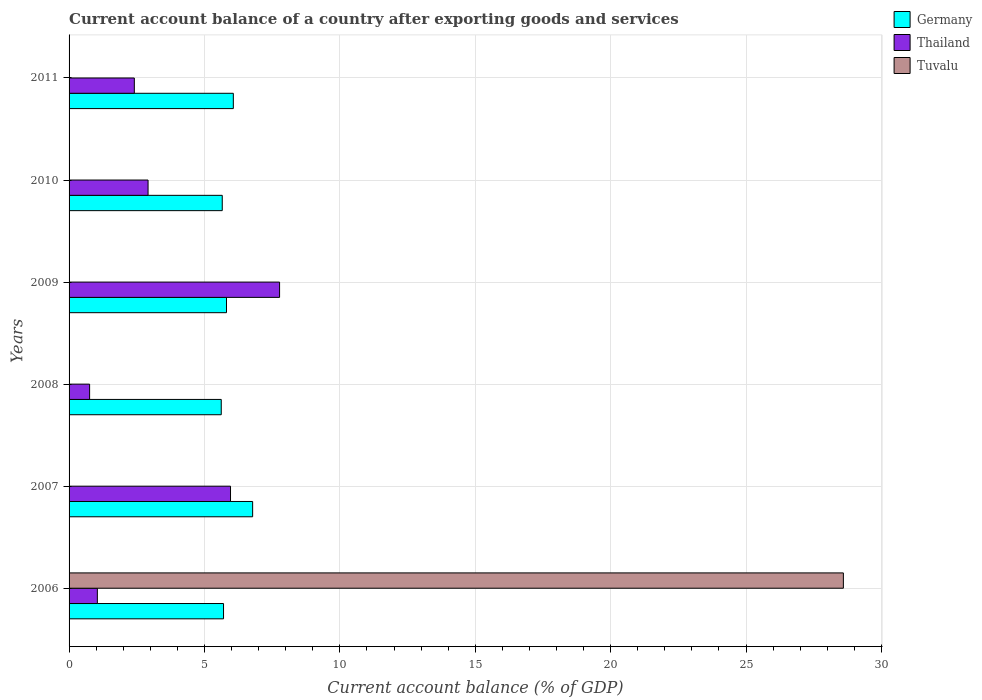How many different coloured bars are there?
Give a very brief answer. 3. Are the number of bars on each tick of the Y-axis equal?
Provide a succinct answer. No. How many bars are there on the 2nd tick from the bottom?
Offer a terse response. 2. In how many cases, is the number of bars for a given year not equal to the number of legend labels?
Give a very brief answer. 5. What is the account balance in Thailand in 2008?
Ensure brevity in your answer.  0.76. Across all years, what is the maximum account balance in Thailand?
Offer a terse response. 7.77. What is the total account balance in Thailand in the graph?
Ensure brevity in your answer.  20.87. What is the difference between the account balance in Germany in 2006 and that in 2007?
Offer a very short reply. -1.08. What is the difference between the account balance in Tuvalu in 2009 and the account balance in Germany in 2008?
Ensure brevity in your answer.  -5.62. What is the average account balance in Thailand per year?
Offer a terse response. 3.48. In the year 2007, what is the difference between the account balance in Thailand and account balance in Germany?
Give a very brief answer. -0.82. In how many years, is the account balance in Thailand greater than 20 %?
Make the answer very short. 0. What is the ratio of the account balance in Thailand in 2006 to that in 2009?
Keep it short and to the point. 0.13. Is the difference between the account balance in Thailand in 2006 and 2009 greater than the difference between the account balance in Germany in 2006 and 2009?
Your answer should be compact. No. What is the difference between the highest and the second highest account balance in Thailand?
Your response must be concise. 1.81. What is the difference between the highest and the lowest account balance in Tuvalu?
Offer a very short reply. 28.6. In how many years, is the account balance in Germany greater than the average account balance in Germany taken over all years?
Provide a short and direct response. 2. Is the sum of the account balance in Germany in 2007 and 2011 greater than the maximum account balance in Tuvalu across all years?
Keep it short and to the point. No. Is it the case that in every year, the sum of the account balance in Thailand and account balance in Tuvalu is greater than the account balance in Germany?
Your answer should be compact. No. How many bars are there?
Provide a short and direct response. 13. Are all the bars in the graph horizontal?
Give a very brief answer. Yes. What is the difference between two consecutive major ticks on the X-axis?
Your answer should be very brief. 5. Are the values on the major ticks of X-axis written in scientific E-notation?
Your answer should be compact. No. Does the graph contain any zero values?
Give a very brief answer. Yes. Does the graph contain grids?
Offer a terse response. Yes. Where does the legend appear in the graph?
Make the answer very short. Top right. What is the title of the graph?
Your answer should be very brief. Current account balance of a country after exporting goods and services. Does "Sub-Saharan Africa (all income levels)" appear as one of the legend labels in the graph?
Your answer should be compact. No. What is the label or title of the X-axis?
Offer a terse response. Current account balance (% of GDP). What is the Current account balance (% of GDP) in Germany in 2006?
Your answer should be compact. 5.7. What is the Current account balance (% of GDP) in Thailand in 2006?
Your response must be concise. 1.04. What is the Current account balance (% of GDP) in Tuvalu in 2006?
Give a very brief answer. 28.6. What is the Current account balance (% of GDP) of Germany in 2007?
Provide a short and direct response. 6.78. What is the Current account balance (% of GDP) in Thailand in 2007?
Ensure brevity in your answer.  5.96. What is the Current account balance (% of GDP) in Germany in 2008?
Provide a short and direct response. 5.62. What is the Current account balance (% of GDP) of Thailand in 2008?
Keep it short and to the point. 0.76. What is the Current account balance (% of GDP) in Tuvalu in 2008?
Give a very brief answer. 0. What is the Current account balance (% of GDP) of Germany in 2009?
Make the answer very short. 5.81. What is the Current account balance (% of GDP) of Thailand in 2009?
Make the answer very short. 7.77. What is the Current account balance (% of GDP) of Germany in 2010?
Provide a succinct answer. 5.66. What is the Current account balance (% of GDP) in Thailand in 2010?
Provide a short and direct response. 2.92. What is the Current account balance (% of GDP) of Germany in 2011?
Give a very brief answer. 6.07. What is the Current account balance (% of GDP) in Thailand in 2011?
Provide a short and direct response. 2.41. Across all years, what is the maximum Current account balance (% of GDP) of Germany?
Your answer should be very brief. 6.78. Across all years, what is the maximum Current account balance (% of GDP) of Thailand?
Ensure brevity in your answer.  7.77. Across all years, what is the maximum Current account balance (% of GDP) in Tuvalu?
Offer a very short reply. 28.6. Across all years, what is the minimum Current account balance (% of GDP) in Germany?
Offer a very short reply. 5.62. Across all years, what is the minimum Current account balance (% of GDP) of Thailand?
Provide a succinct answer. 0.76. What is the total Current account balance (% of GDP) of Germany in the graph?
Provide a short and direct response. 35.64. What is the total Current account balance (% of GDP) of Thailand in the graph?
Ensure brevity in your answer.  20.87. What is the total Current account balance (% of GDP) of Tuvalu in the graph?
Your answer should be compact. 28.6. What is the difference between the Current account balance (% of GDP) of Germany in 2006 and that in 2007?
Your answer should be compact. -1.08. What is the difference between the Current account balance (% of GDP) in Thailand in 2006 and that in 2007?
Provide a succinct answer. -4.92. What is the difference between the Current account balance (% of GDP) in Germany in 2006 and that in 2008?
Offer a very short reply. 0.08. What is the difference between the Current account balance (% of GDP) in Thailand in 2006 and that in 2008?
Your answer should be compact. 0.29. What is the difference between the Current account balance (% of GDP) of Germany in 2006 and that in 2009?
Provide a short and direct response. -0.11. What is the difference between the Current account balance (% of GDP) of Thailand in 2006 and that in 2009?
Offer a very short reply. -6.73. What is the difference between the Current account balance (% of GDP) of Germany in 2006 and that in 2010?
Your response must be concise. 0.05. What is the difference between the Current account balance (% of GDP) of Thailand in 2006 and that in 2010?
Make the answer very short. -1.87. What is the difference between the Current account balance (% of GDP) in Germany in 2006 and that in 2011?
Ensure brevity in your answer.  -0.36. What is the difference between the Current account balance (% of GDP) of Thailand in 2006 and that in 2011?
Ensure brevity in your answer.  -1.37. What is the difference between the Current account balance (% of GDP) in Germany in 2007 and that in 2008?
Make the answer very short. 1.16. What is the difference between the Current account balance (% of GDP) in Thailand in 2007 and that in 2008?
Your response must be concise. 5.2. What is the difference between the Current account balance (% of GDP) in Germany in 2007 and that in 2009?
Provide a short and direct response. 0.97. What is the difference between the Current account balance (% of GDP) in Thailand in 2007 and that in 2009?
Offer a very short reply. -1.81. What is the difference between the Current account balance (% of GDP) of Germany in 2007 and that in 2010?
Keep it short and to the point. 1.12. What is the difference between the Current account balance (% of GDP) of Thailand in 2007 and that in 2010?
Offer a terse response. 3.04. What is the difference between the Current account balance (% of GDP) in Germany in 2007 and that in 2011?
Provide a short and direct response. 0.71. What is the difference between the Current account balance (% of GDP) in Thailand in 2007 and that in 2011?
Give a very brief answer. 3.55. What is the difference between the Current account balance (% of GDP) in Germany in 2008 and that in 2009?
Offer a terse response. -0.19. What is the difference between the Current account balance (% of GDP) in Thailand in 2008 and that in 2009?
Keep it short and to the point. -7.02. What is the difference between the Current account balance (% of GDP) in Germany in 2008 and that in 2010?
Your answer should be very brief. -0.04. What is the difference between the Current account balance (% of GDP) in Thailand in 2008 and that in 2010?
Offer a terse response. -2.16. What is the difference between the Current account balance (% of GDP) in Germany in 2008 and that in 2011?
Offer a very short reply. -0.45. What is the difference between the Current account balance (% of GDP) of Thailand in 2008 and that in 2011?
Ensure brevity in your answer.  -1.65. What is the difference between the Current account balance (% of GDP) of Germany in 2009 and that in 2010?
Give a very brief answer. 0.16. What is the difference between the Current account balance (% of GDP) in Thailand in 2009 and that in 2010?
Your answer should be very brief. 4.86. What is the difference between the Current account balance (% of GDP) in Germany in 2009 and that in 2011?
Provide a succinct answer. -0.25. What is the difference between the Current account balance (% of GDP) of Thailand in 2009 and that in 2011?
Offer a terse response. 5.36. What is the difference between the Current account balance (% of GDP) of Germany in 2010 and that in 2011?
Offer a very short reply. -0.41. What is the difference between the Current account balance (% of GDP) in Thailand in 2010 and that in 2011?
Give a very brief answer. 0.51. What is the difference between the Current account balance (% of GDP) in Germany in 2006 and the Current account balance (% of GDP) in Thailand in 2007?
Ensure brevity in your answer.  -0.26. What is the difference between the Current account balance (% of GDP) in Germany in 2006 and the Current account balance (% of GDP) in Thailand in 2008?
Your answer should be very brief. 4.95. What is the difference between the Current account balance (% of GDP) in Germany in 2006 and the Current account balance (% of GDP) in Thailand in 2009?
Provide a short and direct response. -2.07. What is the difference between the Current account balance (% of GDP) in Germany in 2006 and the Current account balance (% of GDP) in Thailand in 2010?
Offer a very short reply. 2.79. What is the difference between the Current account balance (% of GDP) in Germany in 2006 and the Current account balance (% of GDP) in Thailand in 2011?
Offer a very short reply. 3.29. What is the difference between the Current account balance (% of GDP) in Germany in 2007 and the Current account balance (% of GDP) in Thailand in 2008?
Your answer should be compact. 6.02. What is the difference between the Current account balance (% of GDP) in Germany in 2007 and the Current account balance (% of GDP) in Thailand in 2009?
Make the answer very short. -0.99. What is the difference between the Current account balance (% of GDP) in Germany in 2007 and the Current account balance (% of GDP) in Thailand in 2010?
Your answer should be very brief. 3.86. What is the difference between the Current account balance (% of GDP) in Germany in 2007 and the Current account balance (% of GDP) in Thailand in 2011?
Ensure brevity in your answer.  4.37. What is the difference between the Current account balance (% of GDP) of Germany in 2008 and the Current account balance (% of GDP) of Thailand in 2009?
Provide a short and direct response. -2.15. What is the difference between the Current account balance (% of GDP) in Germany in 2008 and the Current account balance (% of GDP) in Thailand in 2010?
Provide a succinct answer. 2.7. What is the difference between the Current account balance (% of GDP) in Germany in 2008 and the Current account balance (% of GDP) in Thailand in 2011?
Provide a short and direct response. 3.21. What is the difference between the Current account balance (% of GDP) in Germany in 2009 and the Current account balance (% of GDP) in Thailand in 2010?
Keep it short and to the point. 2.9. What is the difference between the Current account balance (% of GDP) in Germany in 2009 and the Current account balance (% of GDP) in Thailand in 2011?
Offer a terse response. 3.4. What is the difference between the Current account balance (% of GDP) of Germany in 2010 and the Current account balance (% of GDP) of Thailand in 2011?
Your answer should be very brief. 3.25. What is the average Current account balance (% of GDP) of Germany per year?
Offer a very short reply. 5.94. What is the average Current account balance (% of GDP) of Thailand per year?
Offer a terse response. 3.48. What is the average Current account balance (% of GDP) of Tuvalu per year?
Make the answer very short. 4.77. In the year 2006, what is the difference between the Current account balance (% of GDP) in Germany and Current account balance (% of GDP) in Thailand?
Provide a short and direct response. 4.66. In the year 2006, what is the difference between the Current account balance (% of GDP) in Germany and Current account balance (% of GDP) in Tuvalu?
Keep it short and to the point. -22.89. In the year 2006, what is the difference between the Current account balance (% of GDP) of Thailand and Current account balance (% of GDP) of Tuvalu?
Your response must be concise. -27.55. In the year 2007, what is the difference between the Current account balance (% of GDP) of Germany and Current account balance (% of GDP) of Thailand?
Provide a short and direct response. 0.82. In the year 2008, what is the difference between the Current account balance (% of GDP) in Germany and Current account balance (% of GDP) in Thailand?
Your answer should be compact. 4.86. In the year 2009, what is the difference between the Current account balance (% of GDP) of Germany and Current account balance (% of GDP) of Thailand?
Provide a short and direct response. -1.96. In the year 2010, what is the difference between the Current account balance (% of GDP) of Germany and Current account balance (% of GDP) of Thailand?
Provide a succinct answer. 2.74. In the year 2011, what is the difference between the Current account balance (% of GDP) in Germany and Current account balance (% of GDP) in Thailand?
Provide a short and direct response. 3.66. What is the ratio of the Current account balance (% of GDP) in Germany in 2006 to that in 2007?
Provide a short and direct response. 0.84. What is the ratio of the Current account balance (% of GDP) of Thailand in 2006 to that in 2007?
Your answer should be compact. 0.18. What is the ratio of the Current account balance (% of GDP) of Germany in 2006 to that in 2008?
Ensure brevity in your answer.  1.01. What is the ratio of the Current account balance (% of GDP) of Thailand in 2006 to that in 2008?
Your answer should be compact. 1.38. What is the ratio of the Current account balance (% of GDP) in Germany in 2006 to that in 2009?
Give a very brief answer. 0.98. What is the ratio of the Current account balance (% of GDP) in Thailand in 2006 to that in 2009?
Your answer should be compact. 0.13. What is the ratio of the Current account balance (% of GDP) of Germany in 2006 to that in 2010?
Offer a terse response. 1.01. What is the ratio of the Current account balance (% of GDP) of Thailand in 2006 to that in 2010?
Give a very brief answer. 0.36. What is the ratio of the Current account balance (% of GDP) in Germany in 2006 to that in 2011?
Offer a terse response. 0.94. What is the ratio of the Current account balance (% of GDP) in Thailand in 2006 to that in 2011?
Your answer should be compact. 0.43. What is the ratio of the Current account balance (% of GDP) of Germany in 2007 to that in 2008?
Make the answer very short. 1.21. What is the ratio of the Current account balance (% of GDP) in Thailand in 2007 to that in 2008?
Provide a succinct answer. 7.86. What is the ratio of the Current account balance (% of GDP) in Germany in 2007 to that in 2009?
Keep it short and to the point. 1.17. What is the ratio of the Current account balance (% of GDP) of Thailand in 2007 to that in 2009?
Your answer should be very brief. 0.77. What is the ratio of the Current account balance (% of GDP) of Germany in 2007 to that in 2010?
Give a very brief answer. 1.2. What is the ratio of the Current account balance (% of GDP) of Thailand in 2007 to that in 2010?
Give a very brief answer. 2.04. What is the ratio of the Current account balance (% of GDP) in Germany in 2007 to that in 2011?
Give a very brief answer. 1.12. What is the ratio of the Current account balance (% of GDP) of Thailand in 2007 to that in 2011?
Make the answer very short. 2.47. What is the ratio of the Current account balance (% of GDP) in Germany in 2008 to that in 2009?
Your answer should be compact. 0.97. What is the ratio of the Current account balance (% of GDP) of Thailand in 2008 to that in 2009?
Your answer should be compact. 0.1. What is the ratio of the Current account balance (% of GDP) of Thailand in 2008 to that in 2010?
Keep it short and to the point. 0.26. What is the ratio of the Current account balance (% of GDP) in Germany in 2008 to that in 2011?
Provide a succinct answer. 0.93. What is the ratio of the Current account balance (% of GDP) of Thailand in 2008 to that in 2011?
Your answer should be compact. 0.31. What is the ratio of the Current account balance (% of GDP) in Germany in 2009 to that in 2010?
Offer a very short reply. 1.03. What is the ratio of the Current account balance (% of GDP) in Thailand in 2009 to that in 2010?
Provide a short and direct response. 2.66. What is the ratio of the Current account balance (% of GDP) of Germany in 2009 to that in 2011?
Give a very brief answer. 0.96. What is the ratio of the Current account balance (% of GDP) in Thailand in 2009 to that in 2011?
Your answer should be compact. 3.23. What is the ratio of the Current account balance (% of GDP) of Germany in 2010 to that in 2011?
Your answer should be very brief. 0.93. What is the ratio of the Current account balance (% of GDP) of Thailand in 2010 to that in 2011?
Your response must be concise. 1.21. What is the difference between the highest and the second highest Current account balance (% of GDP) in Germany?
Your answer should be very brief. 0.71. What is the difference between the highest and the second highest Current account balance (% of GDP) in Thailand?
Provide a short and direct response. 1.81. What is the difference between the highest and the lowest Current account balance (% of GDP) in Germany?
Make the answer very short. 1.16. What is the difference between the highest and the lowest Current account balance (% of GDP) of Thailand?
Your answer should be compact. 7.02. What is the difference between the highest and the lowest Current account balance (% of GDP) of Tuvalu?
Provide a succinct answer. 28.6. 